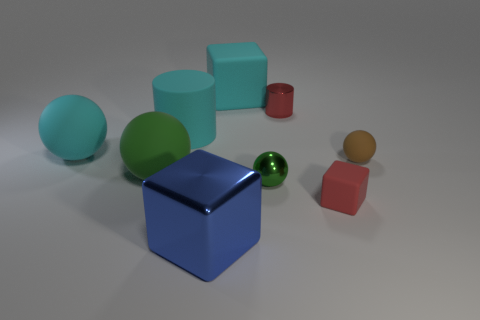How many large cyan spheres are to the left of the small brown matte thing?
Your answer should be very brief. 1. Are there fewer large spheres on the left side of the big green matte sphere than rubber things in front of the cyan sphere?
Offer a very short reply. Yes. How many blue metallic spheres are there?
Your response must be concise. 0. The rubber cube behind the rubber cylinder is what color?
Your answer should be very brief. Cyan. What size is the cyan rubber cylinder?
Your answer should be compact. Large. Does the small cylinder have the same color as the rubber cube that is in front of the cyan matte cylinder?
Provide a short and direct response. Yes. What is the color of the block on the right side of the matte cube behind the big cyan matte sphere?
Give a very brief answer. Red. Is the shape of the tiny matte object in front of the brown thing the same as  the blue metallic thing?
Give a very brief answer. Yes. How many blocks are behind the metallic cylinder and in front of the green rubber ball?
Offer a very short reply. 0. There is a block that is on the left side of the matte object that is behind the small red object that is behind the small red block; what is its color?
Offer a terse response. Blue. 